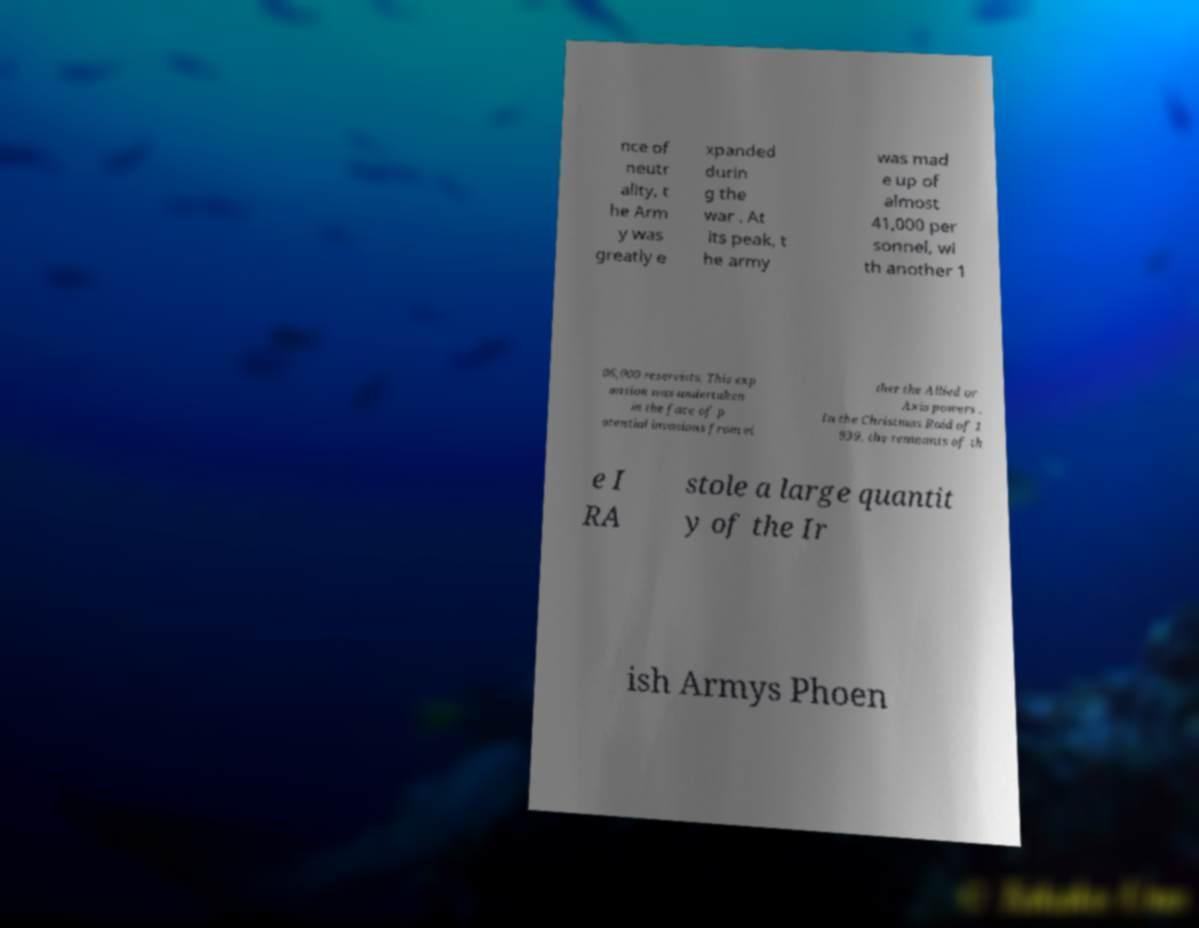Could you assist in decoding the text presented in this image and type it out clearly? nce of neutr ality, t he Arm y was greatly e xpanded durin g the war . At its peak, t he army was mad e up of almost 41,000 per sonnel, wi th another 1 06,000 reservists. This exp ansion was undertaken in the face of p otential invasions from ei ther the Allied or Axis powers . In the Christmas Raid of 1 939, the remnants of th e I RA stole a large quantit y of the Ir ish Armys Phoen 